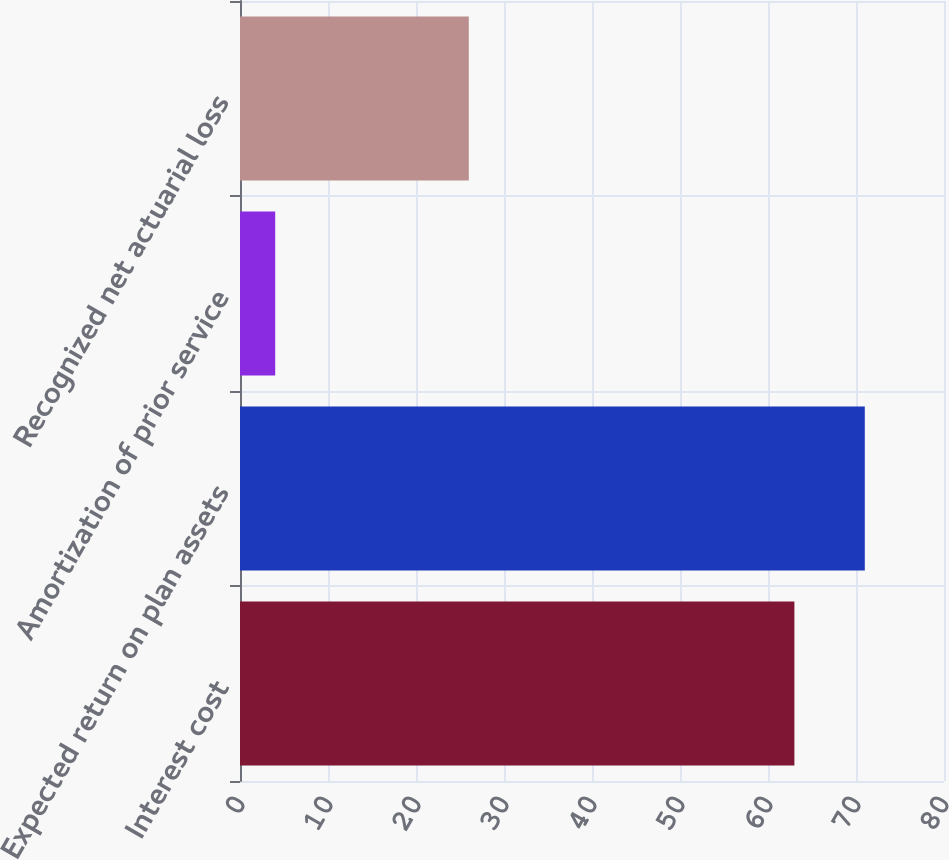<chart> <loc_0><loc_0><loc_500><loc_500><bar_chart><fcel>Interest cost<fcel>Expected return on plan assets<fcel>Amortization of prior service<fcel>Recognized net actuarial loss<nl><fcel>63<fcel>71<fcel>4<fcel>26<nl></chart> 